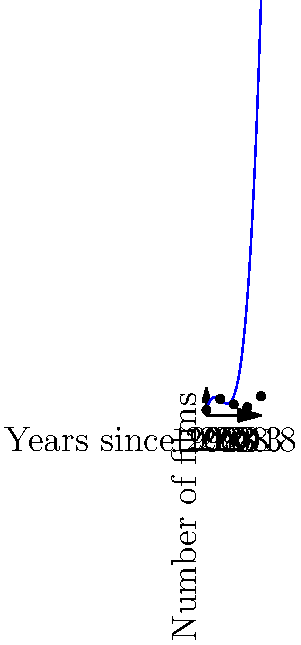Based on the polynomial regression graph showing Santiago Segura's film release frequency over time, what can be inferred about his film production pattern from 1998 to 2018? To analyze Santiago Segura's film release frequency over time:

1. Observe the graph's shape: It's a cubic polynomial, indicating fluctuations in film production.

2. Start point (1998): The graph begins at approximately 2 films.

3. Initial increase (1998-2003): There's a steep rise, peaking around 2003 with about 6 films.

4. Decline phase (2003-2013): Production decreases, reaching a low point of about 3 films around 2013.

5. Recent surge (2013-2018): There's a sharp increase, with production rising to about 7 films by 2018.

6. Overall trend: The pattern shows an initial boom, followed by a period of reduced activity, and then a recent resurgence in film production.

This polynomial regression suggests that Segura's career has gone through distinct phases, with periods of high productivity bookending a slower middle period.
Answer: Initial boom, mid-career slowdown, recent resurgence 